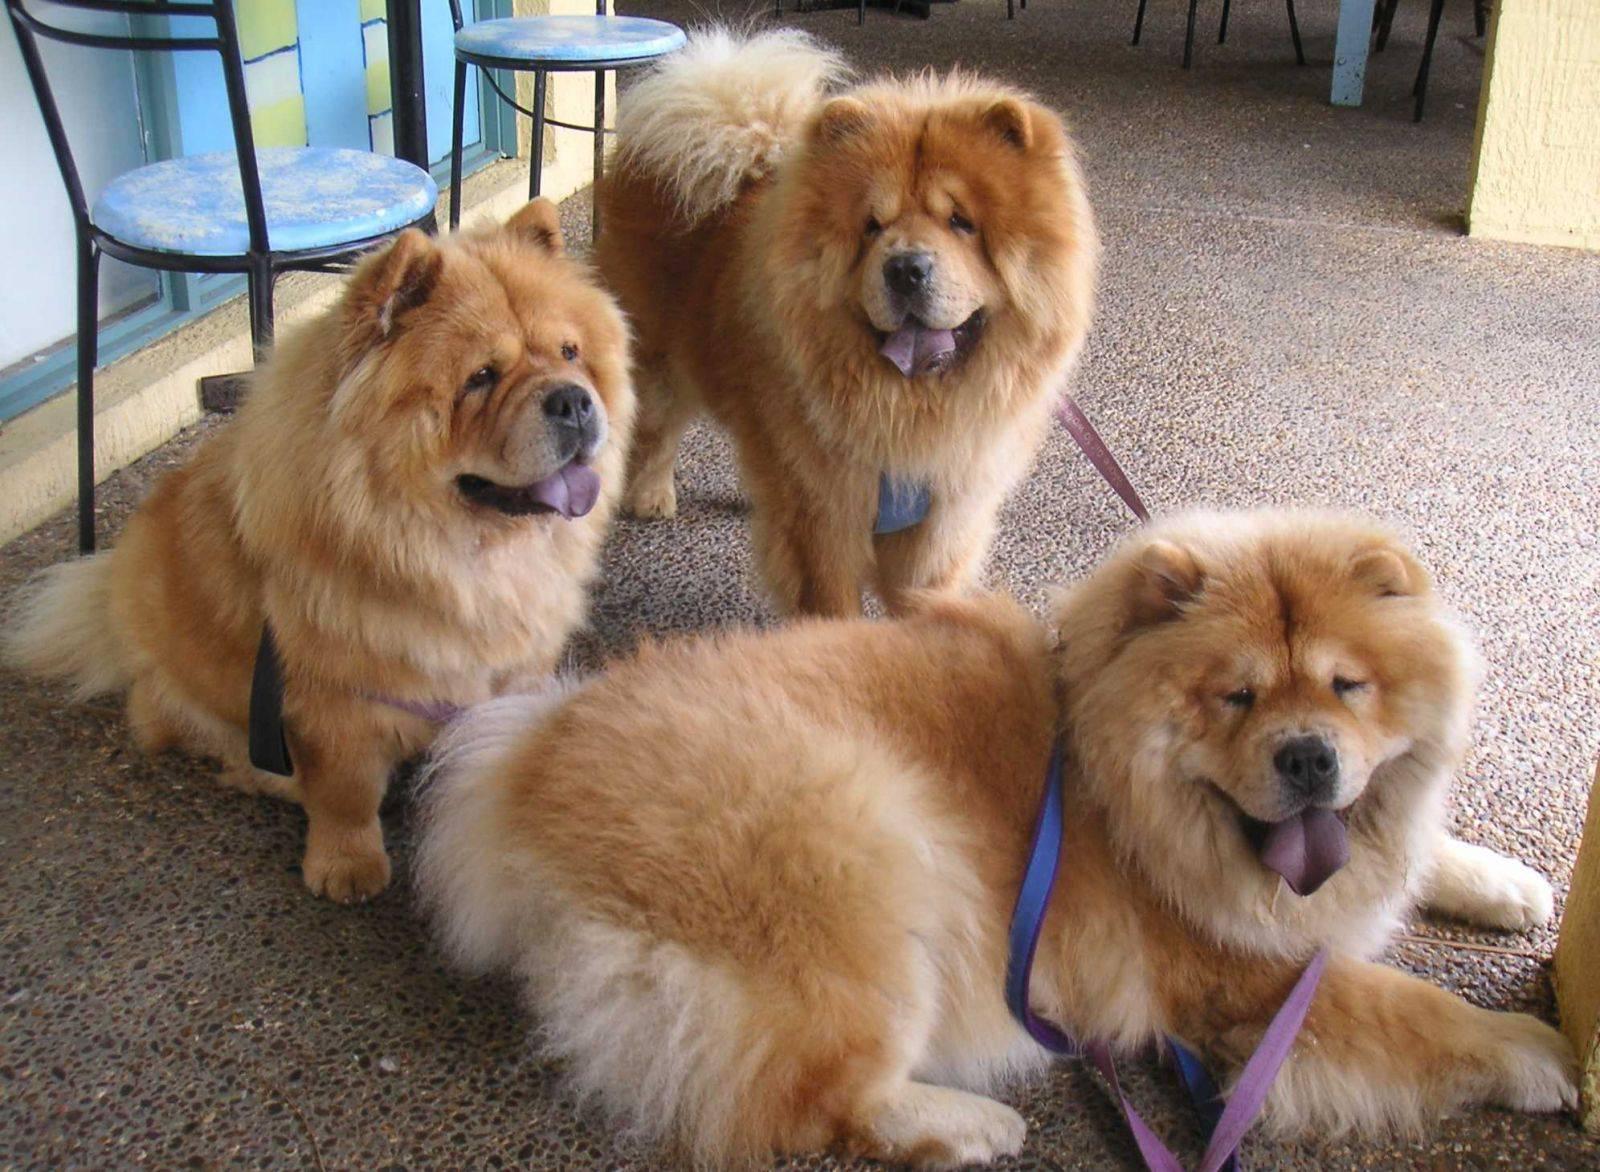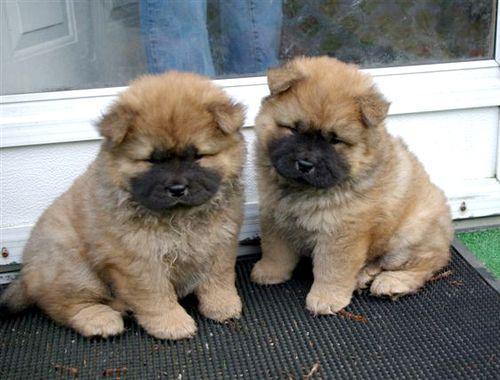The first image is the image on the left, the second image is the image on the right. Assess this claim about the two images: "Exactly four dogs are shown in groups of two.". Correct or not? Answer yes or no. No. 